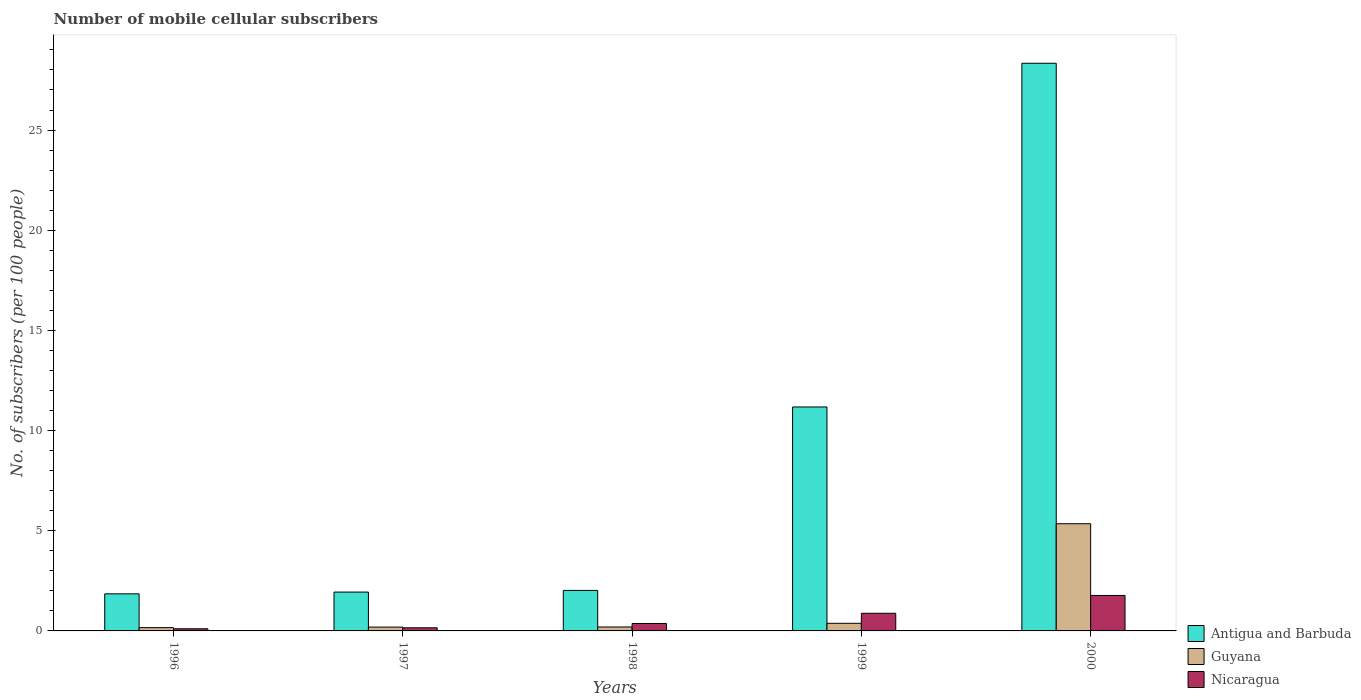How many different coloured bars are there?
Give a very brief answer. 3. Are the number of bars per tick equal to the number of legend labels?
Make the answer very short. Yes. Are the number of bars on each tick of the X-axis equal?
Make the answer very short. Yes. How many bars are there on the 2nd tick from the left?
Offer a terse response. 3. What is the number of mobile cellular subscribers in Guyana in 1998?
Make the answer very short. 0.2. Across all years, what is the maximum number of mobile cellular subscribers in Nicaragua?
Give a very brief answer. 1.77. Across all years, what is the minimum number of mobile cellular subscribers in Antigua and Barbuda?
Your response must be concise. 1.85. In which year was the number of mobile cellular subscribers in Guyana minimum?
Your answer should be very brief. 1996. What is the total number of mobile cellular subscribers in Antigua and Barbuda in the graph?
Keep it short and to the point. 45.32. What is the difference between the number of mobile cellular subscribers in Nicaragua in 1998 and that in 1999?
Provide a short and direct response. -0.51. What is the difference between the number of mobile cellular subscribers in Guyana in 2000 and the number of mobile cellular subscribers in Antigua and Barbuda in 1999?
Your answer should be compact. -5.83. What is the average number of mobile cellular subscribers in Antigua and Barbuda per year?
Your answer should be compact. 9.06. In the year 1997, what is the difference between the number of mobile cellular subscribers in Antigua and Barbuda and number of mobile cellular subscribers in Guyana?
Make the answer very short. 1.75. What is the ratio of the number of mobile cellular subscribers in Guyana in 1996 to that in 1998?
Offer a very short reply. 0.83. What is the difference between the highest and the second highest number of mobile cellular subscribers in Nicaragua?
Make the answer very short. 0.89. What is the difference between the highest and the lowest number of mobile cellular subscribers in Antigua and Barbuda?
Your response must be concise. 26.48. Is the sum of the number of mobile cellular subscribers in Antigua and Barbuda in 1999 and 2000 greater than the maximum number of mobile cellular subscribers in Guyana across all years?
Make the answer very short. Yes. What does the 1st bar from the left in 2000 represents?
Your answer should be compact. Antigua and Barbuda. What does the 3rd bar from the right in 1998 represents?
Offer a very short reply. Antigua and Barbuda. Is it the case that in every year, the sum of the number of mobile cellular subscribers in Guyana and number of mobile cellular subscribers in Nicaragua is greater than the number of mobile cellular subscribers in Antigua and Barbuda?
Your answer should be compact. No. How many bars are there?
Provide a succinct answer. 15. What is the difference between two consecutive major ticks on the Y-axis?
Your answer should be compact. 5. Are the values on the major ticks of Y-axis written in scientific E-notation?
Keep it short and to the point. No. Does the graph contain grids?
Ensure brevity in your answer.  No. What is the title of the graph?
Provide a short and direct response. Number of mobile cellular subscribers. Does "Latin America(developing only)" appear as one of the legend labels in the graph?
Provide a succinct answer. No. What is the label or title of the X-axis?
Your answer should be very brief. Years. What is the label or title of the Y-axis?
Your answer should be very brief. No. of subscribers (per 100 people). What is the No. of subscribers (per 100 people) of Antigua and Barbuda in 1996?
Ensure brevity in your answer.  1.85. What is the No. of subscribers (per 100 people) in Guyana in 1996?
Keep it short and to the point. 0.16. What is the No. of subscribers (per 100 people) of Nicaragua in 1996?
Ensure brevity in your answer.  0.11. What is the No. of subscribers (per 100 people) of Antigua and Barbuda in 1997?
Provide a short and direct response. 1.94. What is the No. of subscribers (per 100 people) of Guyana in 1997?
Offer a terse response. 0.19. What is the No. of subscribers (per 100 people) of Nicaragua in 1997?
Make the answer very short. 0.16. What is the No. of subscribers (per 100 people) in Antigua and Barbuda in 1998?
Provide a succinct answer. 2.02. What is the No. of subscribers (per 100 people) of Guyana in 1998?
Provide a short and direct response. 0.2. What is the No. of subscribers (per 100 people) of Nicaragua in 1998?
Your answer should be very brief. 0.37. What is the No. of subscribers (per 100 people) in Antigua and Barbuda in 1999?
Offer a terse response. 11.18. What is the No. of subscribers (per 100 people) of Guyana in 1999?
Ensure brevity in your answer.  0.38. What is the No. of subscribers (per 100 people) of Nicaragua in 1999?
Your answer should be very brief. 0.88. What is the No. of subscribers (per 100 people) of Antigua and Barbuda in 2000?
Offer a terse response. 28.33. What is the No. of subscribers (per 100 people) of Guyana in 2000?
Offer a terse response. 5.35. What is the No. of subscribers (per 100 people) in Nicaragua in 2000?
Your answer should be very brief. 1.77. Across all years, what is the maximum No. of subscribers (per 100 people) in Antigua and Barbuda?
Your response must be concise. 28.33. Across all years, what is the maximum No. of subscribers (per 100 people) of Guyana?
Offer a very short reply. 5.35. Across all years, what is the maximum No. of subscribers (per 100 people) of Nicaragua?
Offer a very short reply. 1.77. Across all years, what is the minimum No. of subscribers (per 100 people) of Antigua and Barbuda?
Provide a succinct answer. 1.85. Across all years, what is the minimum No. of subscribers (per 100 people) in Guyana?
Offer a very short reply. 0.16. Across all years, what is the minimum No. of subscribers (per 100 people) in Nicaragua?
Offer a very short reply. 0.11. What is the total No. of subscribers (per 100 people) in Antigua and Barbuda in the graph?
Give a very brief answer. 45.32. What is the total No. of subscribers (per 100 people) in Guyana in the graph?
Your answer should be compact. 6.28. What is the total No. of subscribers (per 100 people) in Nicaragua in the graph?
Ensure brevity in your answer.  3.29. What is the difference between the No. of subscribers (per 100 people) in Antigua and Barbuda in 1996 and that in 1997?
Give a very brief answer. -0.09. What is the difference between the No. of subscribers (per 100 people) in Guyana in 1996 and that in 1997?
Your response must be concise. -0.03. What is the difference between the No. of subscribers (per 100 people) of Nicaragua in 1996 and that in 1997?
Ensure brevity in your answer.  -0.05. What is the difference between the No. of subscribers (per 100 people) in Antigua and Barbuda in 1996 and that in 1998?
Keep it short and to the point. -0.17. What is the difference between the No. of subscribers (per 100 people) in Guyana in 1996 and that in 1998?
Keep it short and to the point. -0.03. What is the difference between the No. of subscribers (per 100 people) of Nicaragua in 1996 and that in 1998?
Your response must be concise. -0.26. What is the difference between the No. of subscribers (per 100 people) in Antigua and Barbuda in 1996 and that in 1999?
Offer a terse response. -9.33. What is the difference between the No. of subscribers (per 100 people) of Guyana in 1996 and that in 1999?
Provide a short and direct response. -0.22. What is the difference between the No. of subscribers (per 100 people) in Nicaragua in 1996 and that in 1999?
Your answer should be very brief. -0.77. What is the difference between the No. of subscribers (per 100 people) in Antigua and Barbuda in 1996 and that in 2000?
Ensure brevity in your answer.  -26.48. What is the difference between the No. of subscribers (per 100 people) in Guyana in 1996 and that in 2000?
Keep it short and to the point. -5.19. What is the difference between the No. of subscribers (per 100 people) in Nicaragua in 1996 and that in 2000?
Make the answer very short. -1.66. What is the difference between the No. of subscribers (per 100 people) in Antigua and Barbuda in 1997 and that in 1998?
Provide a succinct answer. -0.08. What is the difference between the No. of subscribers (per 100 people) in Guyana in 1997 and that in 1998?
Your response must be concise. -0.01. What is the difference between the No. of subscribers (per 100 people) of Nicaragua in 1997 and that in 1998?
Offer a terse response. -0.21. What is the difference between the No. of subscribers (per 100 people) in Antigua and Barbuda in 1997 and that in 1999?
Your response must be concise. -9.24. What is the difference between the No. of subscribers (per 100 people) of Guyana in 1997 and that in 1999?
Ensure brevity in your answer.  -0.19. What is the difference between the No. of subscribers (per 100 people) of Nicaragua in 1997 and that in 1999?
Offer a very short reply. -0.72. What is the difference between the No. of subscribers (per 100 people) of Antigua and Barbuda in 1997 and that in 2000?
Provide a succinct answer. -26.39. What is the difference between the No. of subscribers (per 100 people) of Guyana in 1997 and that in 2000?
Make the answer very short. -5.16. What is the difference between the No. of subscribers (per 100 people) of Nicaragua in 1997 and that in 2000?
Keep it short and to the point. -1.61. What is the difference between the No. of subscribers (per 100 people) of Antigua and Barbuda in 1998 and that in 1999?
Ensure brevity in your answer.  -9.16. What is the difference between the No. of subscribers (per 100 people) in Guyana in 1998 and that in 1999?
Offer a very short reply. -0.18. What is the difference between the No. of subscribers (per 100 people) of Nicaragua in 1998 and that in 1999?
Your answer should be very brief. -0.51. What is the difference between the No. of subscribers (per 100 people) in Antigua and Barbuda in 1998 and that in 2000?
Offer a very short reply. -26.31. What is the difference between the No. of subscribers (per 100 people) of Guyana in 1998 and that in 2000?
Give a very brief answer. -5.15. What is the difference between the No. of subscribers (per 100 people) in Nicaragua in 1998 and that in 2000?
Provide a succinct answer. -1.4. What is the difference between the No. of subscribers (per 100 people) of Antigua and Barbuda in 1999 and that in 2000?
Provide a short and direct response. -17.15. What is the difference between the No. of subscribers (per 100 people) of Guyana in 1999 and that in 2000?
Your answer should be compact. -4.97. What is the difference between the No. of subscribers (per 100 people) of Nicaragua in 1999 and that in 2000?
Your answer should be very brief. -0.89. What is the difference between the No. of subscribers (per 100 people) in Antigua and Barbuda in 1996 and the No. of subscribers (per 100 people) in Guyana in 1997?
Keep it short and to the point. 1.66. What is the difference between the No. of subscribers (per 100 people) of Antigua and Barbuda in 1996 and the No. of subscribers (per 100 people) of Nicaragua in 1997?
Give a very brief answer. 1.69. What is the difference between the No. of subscribers (per 100 people) of Guyana in 1996 and the No. of subscribers (per 100 people) of Nicaragua in 1997?
Make the answer very short. 0.01. What is the difference between the No. of subscribers (per 100 people) in Antigua and Barbuda in 1996 and the No. of subscribers (per 100 people) in Guyana in 1998?
Keep it short and to the point. 1.65. What is the difference between the No. of subscribers (per 100 people) in Antigua and Barbuda in 1996 and the No. of subscribers (per 100 people) in Nicaragua in 1998?
Your answer should be very brief. 1.48. What is the difference between the No. of subscribers (per 100 people) in Guyana in 1996 and the No. of subscribers (per 100 people) in Nicaragua in 1998?
Your answer should be very brief. -0.21. What is the difference between the No. of subscribers (per 100 people) of Antigua and Barbuda in 1996 and the No. of subscribers (per 100 people) of Guyana in 1999?
Provide a succinct answer. 1.47. What is the difference between the No. of subscribers (per 100 people) in Antigua and Barbuda in 1996 and the No. of subscribers (per 100 people) in Nicaragua in 1999?
Your response must be concise. 0.97. What is the difference between the No. of subscribers (per 100 people) of Guyana in 1996 and the No. of subscribers (per 100 people) of Nicaragua in 1999?
Make the answer very short. -0.72. What is the difference between the No. of subscribers (per 100 people) in Antigua and Barbuda in 1996 and the No. of subscribers (per 100 people) in Guyana in 2000?
Your answer should be compact. -3.5. What is the difference between the No. of subscribers (per 100 people) of Antigua and Barbuda in 1996 and the No. of subscribers (per 100 people) of Nicaragua in 2000?
Offer a very short reply. 0.08. What is the difference between the No. of subscribers (per 100 people) in Guyana in 1996 and the No. of subscribers (per 100 people) in Nicaragua in 2000?
Make the answer very short. -1.61. What is the difference between the No. of subscribers (per 100 people) of Antigua and Barbuda in 1997 and the No. of subscribers (per 100 people) of Guyana in 1998?
Offer a very short reply. 1.74. What is the difference between the No. of subscribers (per 100 people) of Antigua and Barbuda in 1997 and the No. of subscribers (per 100 people) of Nicaragua in 1998?
Keep it short and to the point. 1.57. What is the difference between the No. of subscribers (per 100 people) in Guyana in 1997 and the No. of subscribers (per 100 people) in Nicaragua in 1998?
Offer a very short reply. -0.18. What is the difference between the No. of subscribers (per 100 people) of Antigua and Barbuda in 1997 and the No. of subscribers (per 100 people) of Guyana in 1999?
Make the answer very short. 1.56. What is the difference between the No. of subscribers (per 100 people) of Antigua and Barbuda in 1997 and the No. of subscribers (per 100 people) of Nicaragua in 1999?
Your response must be concise. 1.06. What is the difference between the No. of subscribers (per 100 people) in Guyana in 1997 and the No. of subscribers (per 100 people) in Nicaragua in 1999?
Keep it short and to the point. -0.69. What is the difference between the No. of subscribers (per 100 people) of Antigua and Barbuda in 1997 and the No. of subscribers (per 100 people) of Guyana in 2000?
Make the answer very short. -3.41. What is the difference between the No. of subscribers (per 100 people) of Antigua and Barbuda in 1997 and the No. of subscribers (per 100 people) of Nicaragua in 2000?
Provide a short and direct response. 0.17. What is the difference between the No. of subscribers (per 100 people) in Guyana in 1997 and the No. of subscribers (per 100 people) in Nicaragua in 2000?
Keep it short and to the point. -1.58. What is the difference between the No. of subscribers (per 100 people) in Antigua and Barbuda in 1998 and the No. of subscribers (per 100 people) in Guyana in 1999?
Make the answer very short. 1.64. What is the difference between the No. of subscribers (per 100 people) in Antigua and Barbuda in 1998 and the No. of subscribers (per 100 people) in Nicaragua in 1999?
Offer a terse response. 1.14. What is the difference between the No. of subscribers (per 100 people) in Guyana in 1998 and the No. of subscribers (per 100 people) in Nicaragua in 1999?
Keep it short and to the point. -0.68. What is the difference between the No. of subscribers (per 100 people) of Antigua and Barbuda in 1998 and the No. of subscribers (per 100 people) of Guyana in 2000?
Make the answer very short. -3.33. What is the difference between the No. of subscribers (per 100 people) in Antigua and Barbuda in 1998 and the No. of subscribers (per 100 people) in Nicaragua in 2000?
Give a very brief answer. 0.25. What is the difference between the No. of subscribers (per 100 people) in Guyana in 1998 and the No. of subscribers (per 100 people) in Nicaragua in 2000?
Offer a terse response. -1.57. What is the difference between the No. of subscribers (per 100 people) of Antigua and Barbuda in 1999 and the No. of subscribers (per 100 people) of Guyana in 2000?
Make the answer very short. 5.83. What is the difference between the No. of subscribers (per 100 people) in Antigua and Barbuda in 1999 and the No. of subscribers (per 100 people) in Nicaragua in 2000?
Provide a short and direct response. 9.41. What is the difference between the No. of subscribers (per 100 people) in Guyana in 1999 and the No. of subscribers (per 100 people) in Nicaragua in 2000?
Keep it short and to the point. -1.39. What is the average No. of subscribers (per 100 people) of Antigua and Barbuda per year?
Provide a short and direct response. 9.06. What is the average No. of subscribers (per 100 people) in Guyana per year?
Make the answer very short. 1.26. What is the average No. of subscribers (per 100 people) of Nicaragua per year?
Your answer should be very brief. 0.66. In the year 1996, what is the difference between the No. of subscribers (per 100 people) of Antigua and Barbuda and No. of subscribers (per 100 people) of Guyana?
Keep it short and to the point. 1.69. In the year 1996, what is the difference between the No. of subscribers (per 100 people) of Antigua and Barbuda and No. of subscribers (per 100 people) of Nicaragua?
Provide a succinct answer. 1.74. In the year 1996, what is the difference between the No. of subscribers (per 100 people) of Guyana and No. of subscribers (per 100 people) of Nicaragua?
Provide a succinct answer. 0.06. In the year 1997, what is the difference between the No. of subscribers (per 100 people) of Antigua and Barbuda and No. of subscribers (per 100 people) of Guyana?
Ensure brevity in your answer.  1.75. In the year 1997, what is the difference between the No. of subscribers (per 100 people) of Antigua and Barbuda and No. of subscribers (per 100 people) of Nicaragua?
Your response must be concise. 1.78. In the year 1997, what is the difference between the No. of subscribers (per 100 people) in Guyana and No. of subscribers (per 100 people) in Nicaragua?
Keep it short and to the point. 0.03. In the year 1998, what is the difference between the No. of subscribers (per 100 people) of Antigua and Barbuda and No. of subscribers (per 100 people) of Guyana?
Offer a terse response. 1.82. In the year 1998, what is the difference between the No. of subscribers (per 100 people) of Antigua and Barbuda and No. of subscribers (per 100 people) of Nicaragua?
Make the answer very short. 1.65. In the year 1998, what is the difference between the No. of subscribers (per 100 people) of Guyana and No. of subscribers (per 100 people) of Nicaragua?
Ensure brevity in your answer.  -0.17. In the year 1999, what is the difference between the No. of subscribers (per 100 people) of Antigua and Barbuda and No. of subscribers (per 100 people) of Guyana?
Your answer should be compact. 10.8. In the year 1999, what is the difference between the No. of subscribers (per 100 people) in Antigua and Barbuda and No. of subscribers (per 100 people) in Nicaragua?
Give a very brief answer. 10.3. In the year 1999, what is the difference between the No. of subscribers (per 100 people) in Guyana and No. of subscribers (per 100 people) in Nicaragua?
Give a very brief answer. -0.5. In the year 2000, what is the difference between the No. of subscribers (per 100 people) of Antigua and Barbuda and No. of subscribers (per 100 people) of Guyana?
Give a very brief answer. 22.98. In the year 2000, what is the difference between the No. of subscribers (per 100 people) of Antigua and Barbuda and No. of subscribers (per 100 people) of Nicaragua?
Give a very brief answer. 26.56. In the year 2000, what is the difference between the No. of subscribers (per 100 people) in Guyana and No. of subscribers (per 100 people) in Nicaragua?
Provide a succinct answer. 3.58. What is the ratio of the No. of subscribers (per 100 people) in Antigua and Barbuda in 1996 to that in 1997?
Ensure brevity in your answer.  0.95. What is the ratio of the No. of subscribers (per 100 people) in Guyana in 1996 to that in 1997?
Keep it short and to the point. 0.86. What is the ratio of the No. of subscribers (per 100 people) of Nicaragua in 1996 to that in 1997?
Provide a succinct answer. 0.69. What is the ratio of the No. of subscribers (per 100 people) in Antigua and Barbuda in 1996 to that in 1998?
Offer a terse response. 0.92. What is the ratio of the No. of subscribers (per 100 people) of Guyana in 1996 to that in 1998?
Provide a short and direct response. 0.83. What is the ratio of the No. of subscribers (per 100 people) in Nicaragua in 1996 to that in 1998?
Your answer should be very brief. 0.29. What is the ratio of the No. of subscribers (per 100 people) of Antigua and Barbuda in 1996 to that in 1999?
Keep it short and to the point. 0.17. What is the ratio of the No. of subscribers (per 100 people) in Guyana in 1996 to that in 1999?
Your response must be concise. 0.43. What is the ratio of the No. of subscribers (per 100 people) of Nicaragua in 1996 to that in 1999?
Keep it short and to the point. 0.12. What is the ratio of the No. of subscribers (per 100 people) in Antigua and Barbuda in 1996 to that in 2000?
Offer a very short reply. 0.07. What is the ratio of the No. of subscribers (per 100 people) of Guyana in 1996 to that in 2000?
Make the answer very short. 0.03. What is the ratio of the No. of subscribers (per 100 people) of Nicaragua in 1996 to that in 2000?
Your response must be concise. 0.06. What is the ratio of the No. of subscribers (per 100 people) of Antigua and Barbuda in 1997 to that in 1998?
Your answer should be very brief. 0.96. What is the ratio of the No. of subscribers (per 100 people) in Guyana in 1997 to that in 1998?
Provide a short and direct response. 0.97. What is the ratio of the No. of subscribers (per 100 people) of Nicaragua in 1997 to that in 1998?
Your answer should be compact. 0.42. What is the ratio of the No. of subscribers (per 100 people) of Antigua and Barbuda in 1997 to that in 1999?
Your answer should be very brief. 0.17. What is the ratio of the No. of subscribers (per 100 people) in Guyana in 1997 to that in 1999?
Provide a succinct answer. 0.5. What is the ratio of the No. of subscribers (per 100 people) in Nicaragua in 1997 to that in 1999?
Provide a succinct answer. 0.18. What is the ratio of the No. of subscribers (per 100 people) in Antigua and Barbuda in 1997 to that in 2000?
Give a very brief answer. 0.07. What is the ratio of the No. of subscribers (per 100 people) in Guyana in 1997 to that in 2000?
Your answer should be very brief. 0.04. What is the ratio of the No. of subscribers (per 100 people) of Nicaragua in 1997 to that in 2000?
Give a very brief answer. 0.09. What is the ratio of the No. of subscribers (per 100 people) in Antigua and Barbuda in 1998 to that in 1999?
Give a very brief answer. 0.18. What is the ratio of the No. of subscribers (per 100 people) in Guyana in 1998 to that in 1999?
Offer a very short reply. 0.52. What is the ratio of the No. of subscribers (per 100 people) of Nicaragua in 1998 to that in 1999?
Offer a very short reply. 0.42. What is the ratio of the No. of subscribers (per 100 people) in Antigua and Barbuda in 1998 to that in 2000?
Make the answer very short. 0.07. What is the ratio of the No. of subscribers (per 100 people) of Guyana in 1998 to that in 2000?
Offer a very short reply. 0.04. What is the ratio of the No. of subscribers (per 100 people) in Nicaragua in 1998 to that in 2000?
Give a very brief answer. 0.21. What is the ratio of the No. of subscribers (per 100 people) in Antigua and Barbuda in 1999 to that in 2000?
Your answer should be very brief. 0.39. What is the ratio of the No. of subscribers (per 100 people) in Guyana in 1999 to that in 2000?
Provide a succinct answer. 0.07. What is the ratio of the No. of subscribers (per 100 people) in Nicaragua in 1999 to that in 2000?
Offer a terse response. 0.5. What is the difference between the highest and the second highest No. of subscribers (per 100 people) in Antigua and Barbuda?
Offer a terse response. 17.15. What is the difference between the highest and the second highest No. of subscribers (per 100 people) in Guyana?
Offer a terse response. 4.97. What is the difference between the highest and the second highest No. of subscribers (per 100 people) in Nicaragua?
Keep it short and to the point. 0.89. What is the difference between the highest and the lowest No. of subscribers (per 100 people) in Antigua and Barbuda?
Your response must be concise. 26.48. What is the difference between the highest and the lowest No. of subscribers (per 100 people) of Guyana?
Your answer should be very brief. 5.19. What is the difference between the highest and the lowest No. of subscribers (per 100 people) of Nicaragua?
Your answer should be compact. 1.66. 